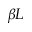Convert formula to latex. <formula><loc_0><loc_0><loc_500><loc_500>\beta L</formula> 